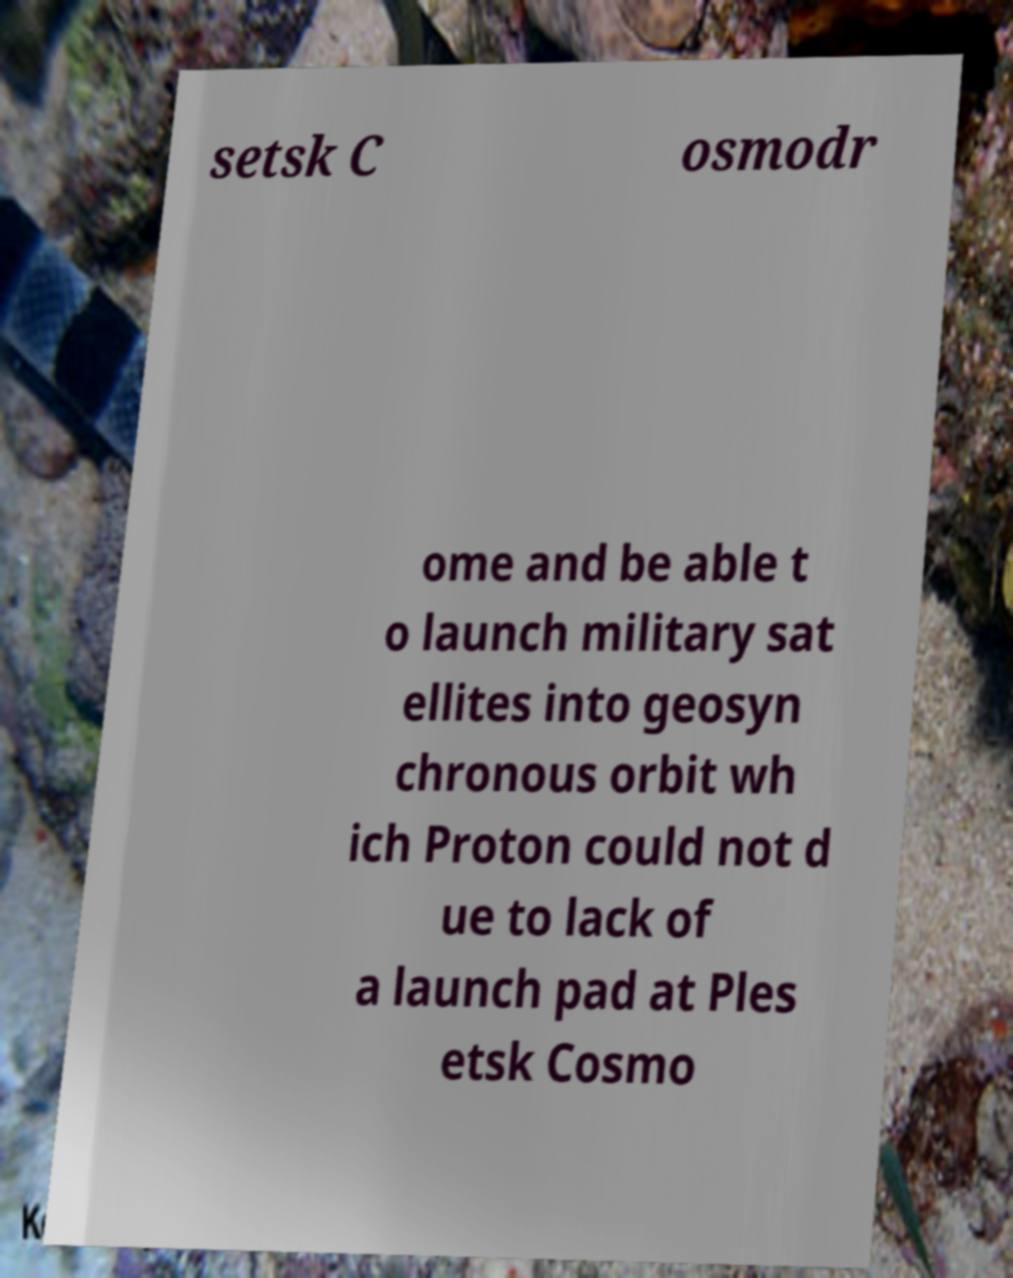Please read and relay the text visible in this image. What does it say? setsk C osmodr ome and be able t o launch military sat ellites into geosyn chronous orbit wh ich Proton could not d ue to lack of a launch pad at Ples etsk Cosmo 